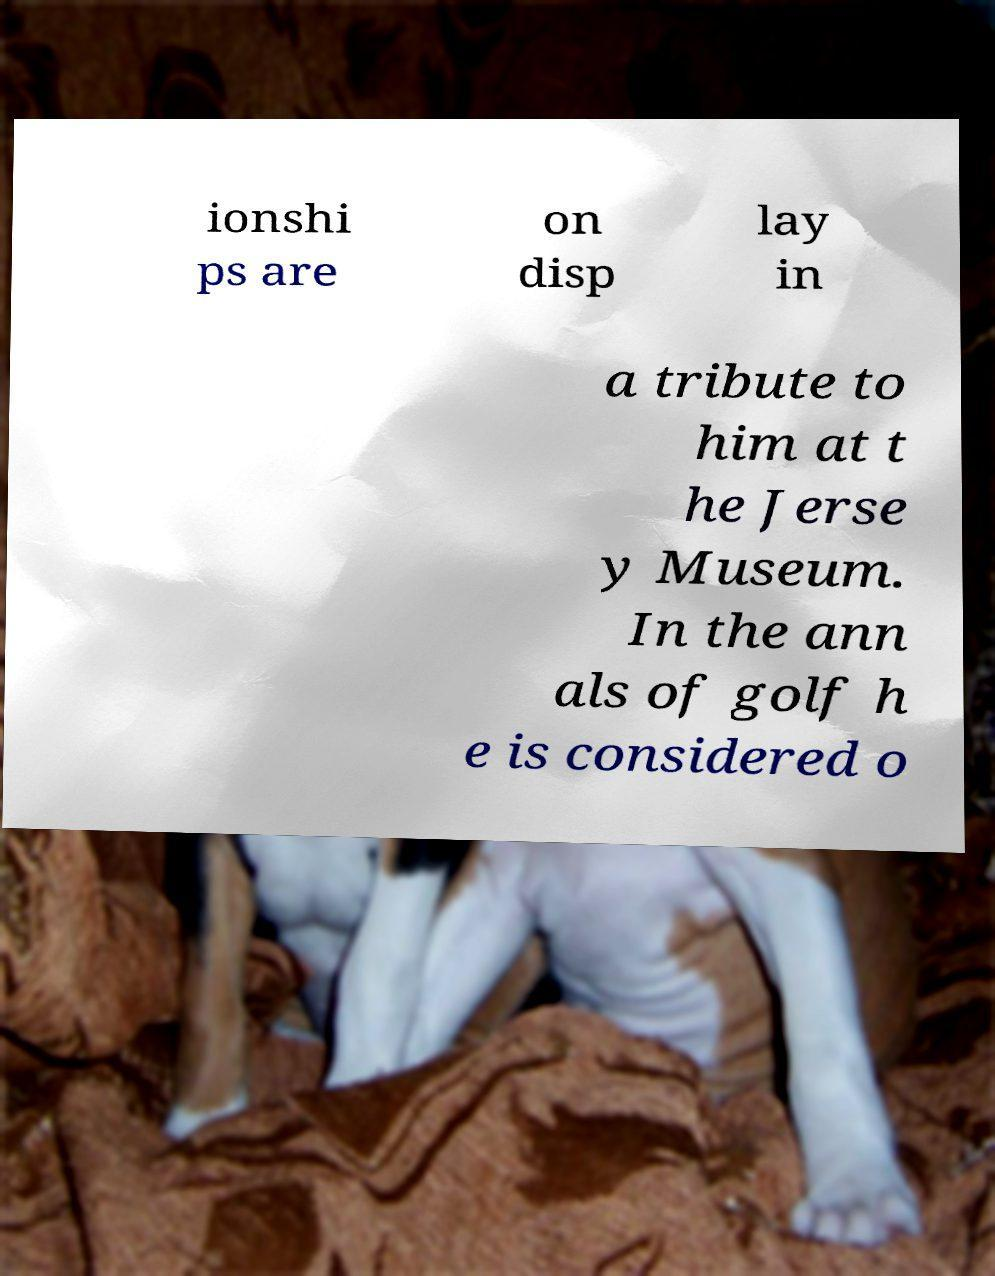Could you assist in decoding the text presented in this image and type it out clearly? ionshi ps are on disp lay in a tribute to him at t he Jerse y Museum. In the ann als of golf h e is considered o 